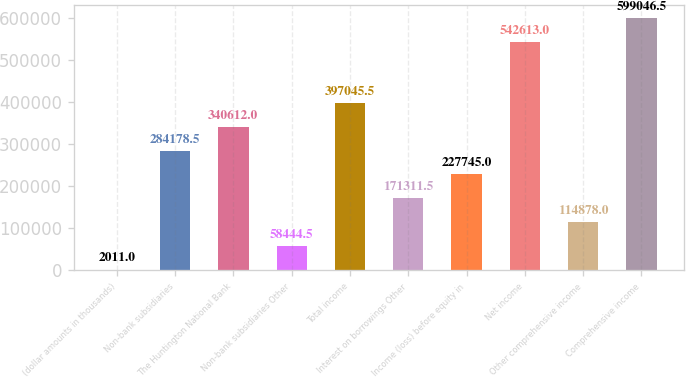Convert chart to OTSL. <chart><loc_0><loc_0><loc_500><loc_500><bar_chart><fcel>(dollar amounts in thousands)<fcel>Non-bank subsidiaries<fcel>The Huntington National Bank<fcel>Non-bank subsidiaries Other<fcel>Total income<fcel>Interest on borrowings Other<fcel>Income (loss) before equity in<fcel>Net income<fcel>Other comprehensive income<fcel>Comprehensive income<nl><fcel>2011<fcel>284178<fcel>340612<fcel>58444.5<fcel>397046<fcel>171312<fcel>227745<fcel>542613<fcel>114878<fcel>599046<nl></chart> 